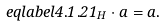Convert formula to latex. <formula><loc_0><loc_0><loc_500><loc_500>\ e q l a b e l { 4 . 1 . 2 } 1 _ { H } \cdot a = a .</formula> 